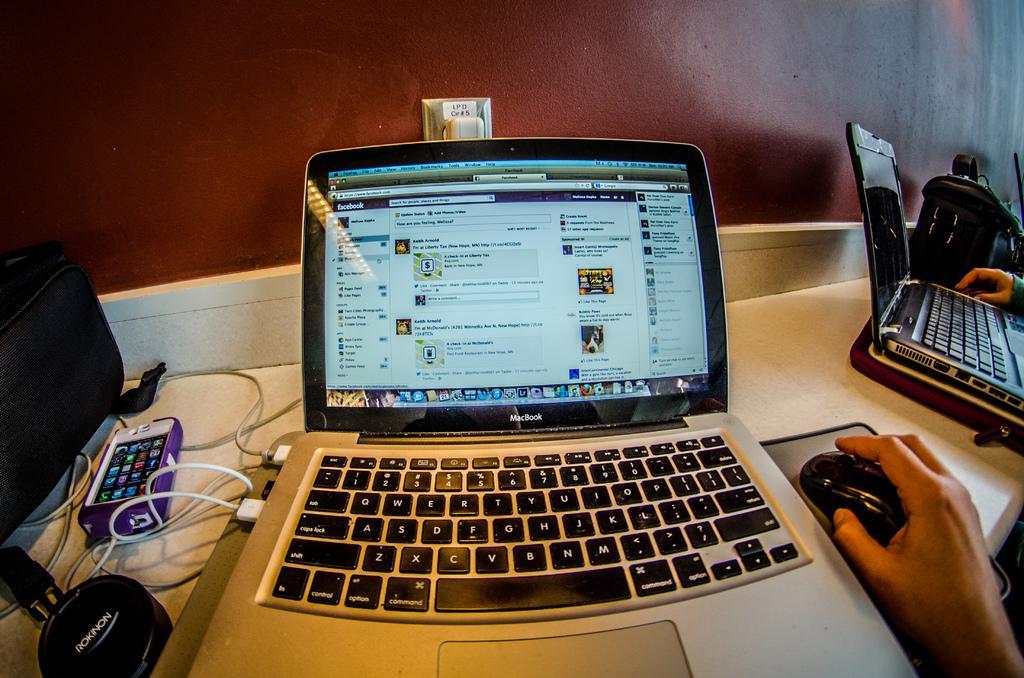How would you summarize this image in a sentence or two? In this image there is a table on which there is a laptop. Beside the laptop there is a man who is holding the mouse. On the left side there is a mobile phone,USB cables. On the right side there is another laptop on the table. Beside the laptop there is a bag. In the background there is a wall. 